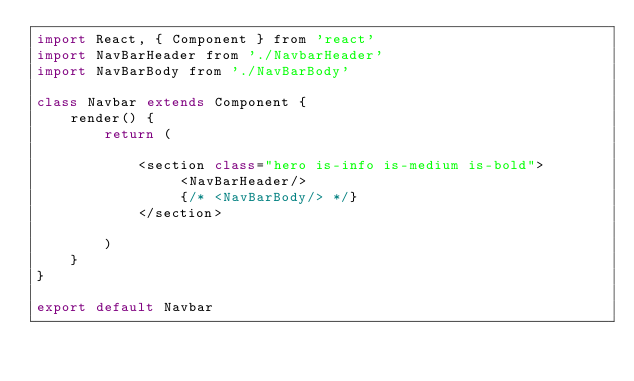Convert code to text. <code><loc_0><loc_0><loc_500><loc_500><_JavaScript_>import React, { Component } from 'react'
import NavBarHeader from './NavbarHeader'
import NavBarBody from './NavBarBody'

class Navbar extends Component {
    render() {
        return (
            
            <section class="hero is-info is-medium is-bold">
                 <NavBarHeader/>
                 {/* <NavBarBody/> */}
            </section>
            
        )
    }
}

export default Navbar


</code> 